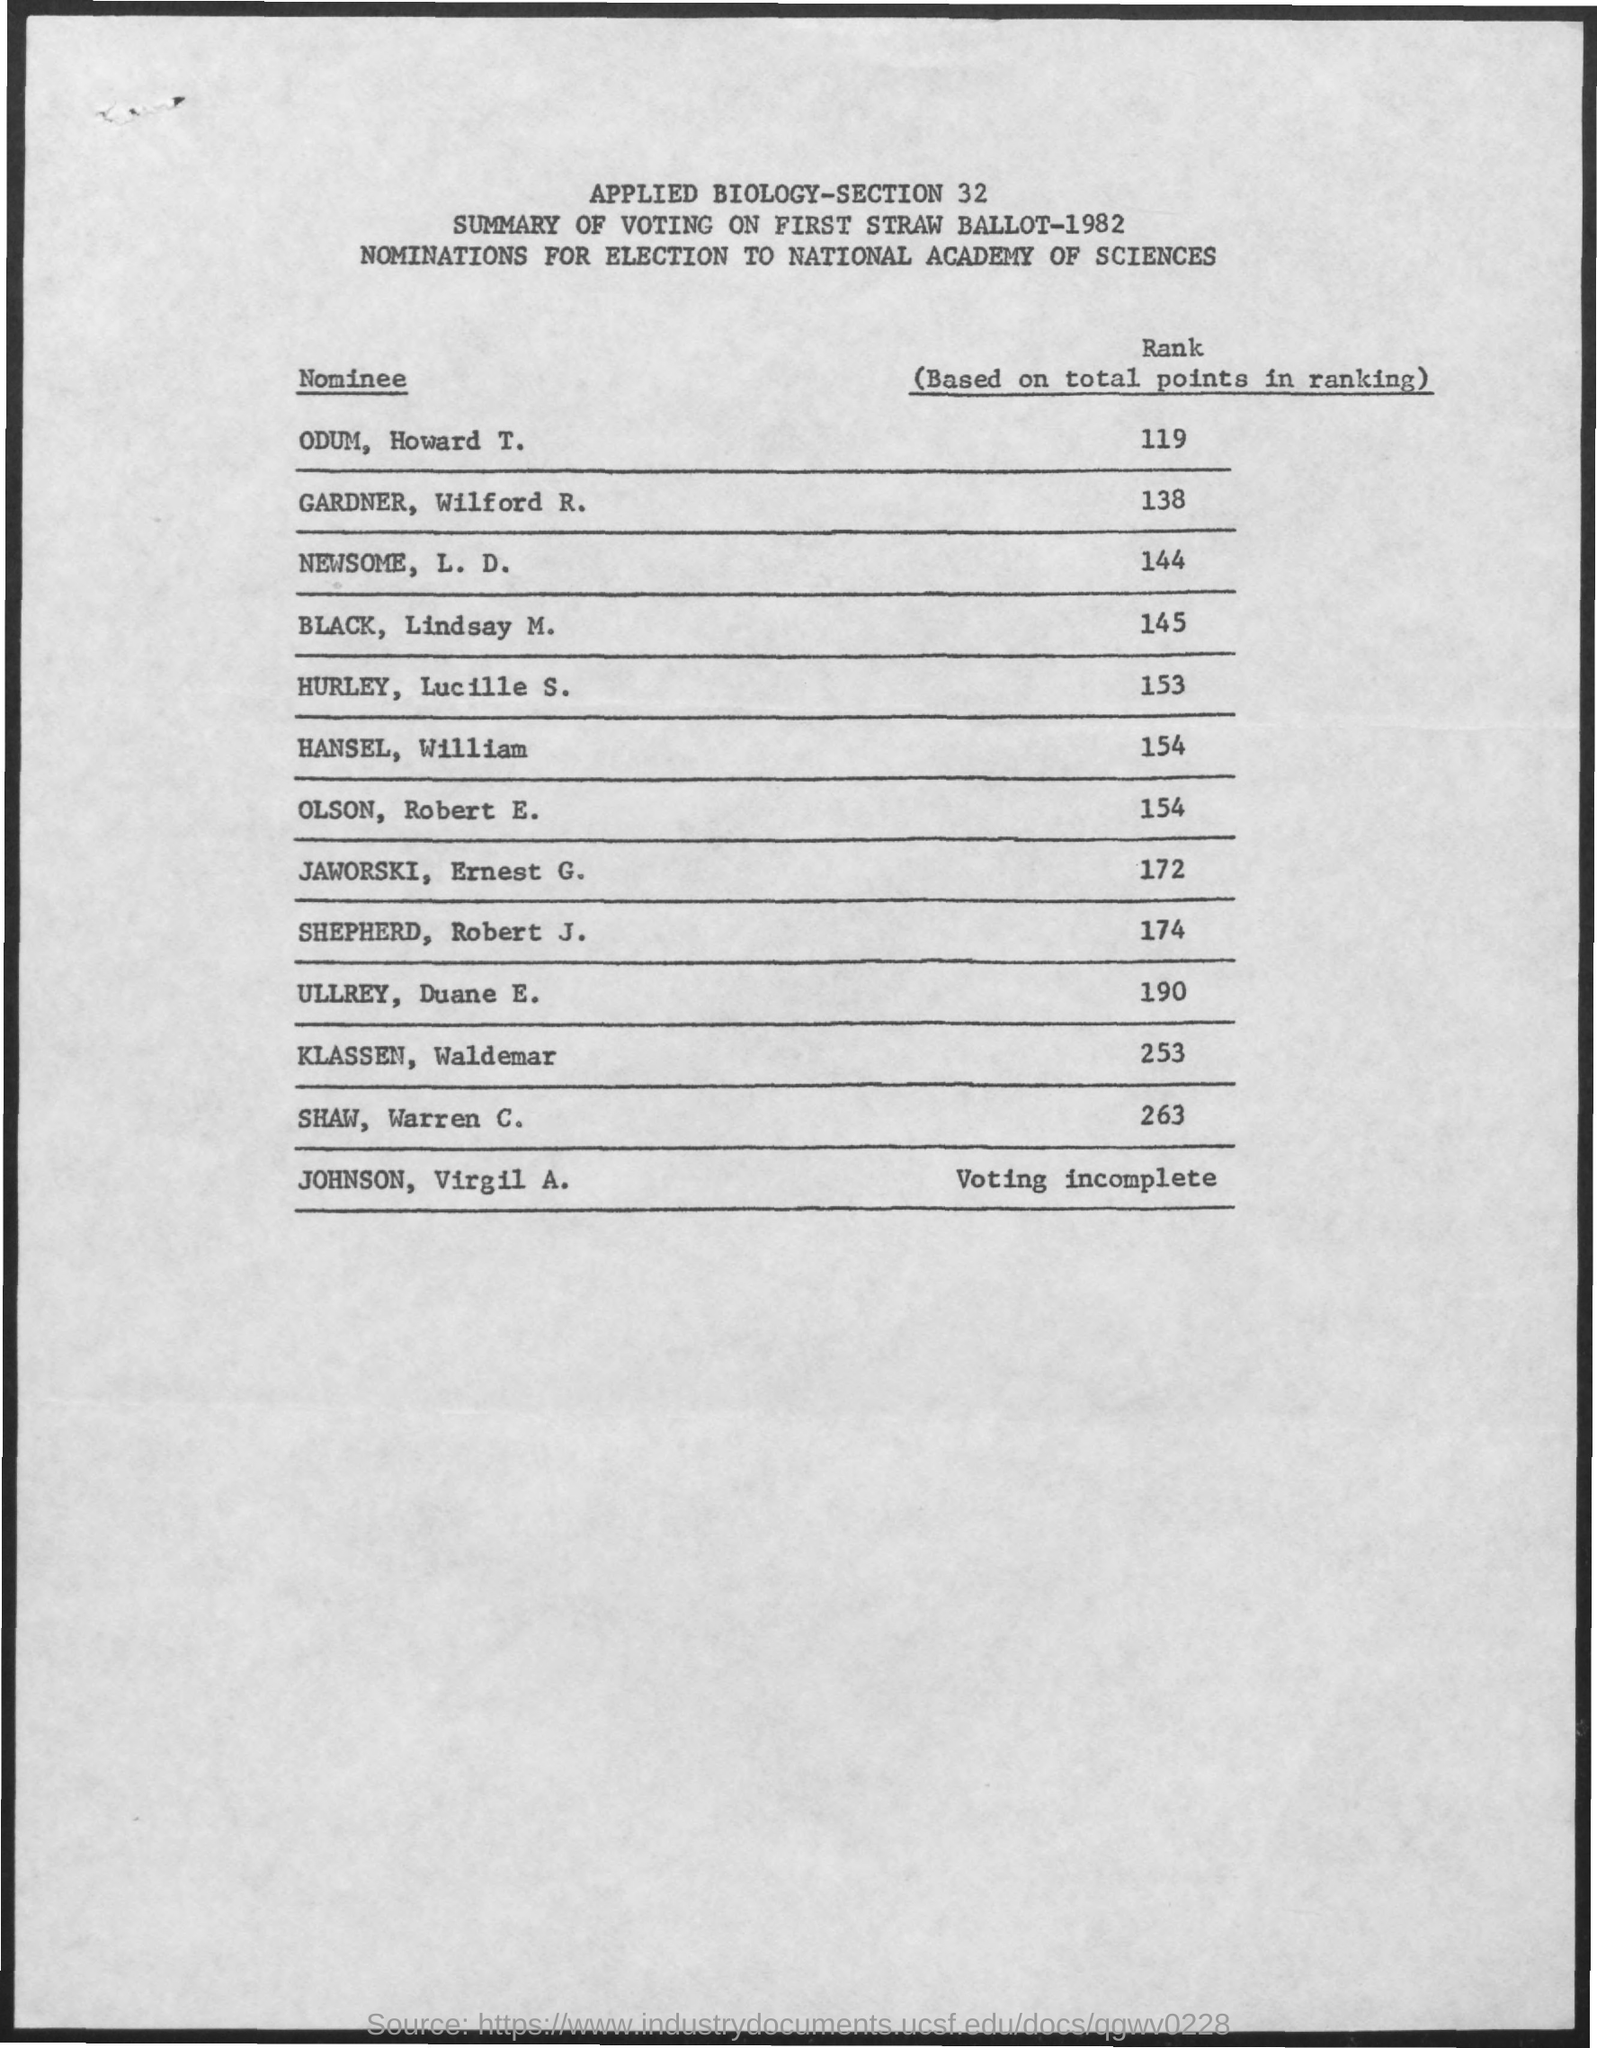Give some essential details in this illustration. The voting of JOHNSON, Virgil A., was incomplete. The nomination for the election to the National Academy of Sciences is currently in progress. Robert J. Shepherd scored 174 points. On the 18th of January, during the 1939 National Basketball League game between the Sheboygan Red Sky and the Milwaukee Hawks, Gardner, Wilford R., scored a monumental 138 points, breaking the previous record of 127 points set by Odessa Allen in 1936. Ullrey, Duane E., scored 190 points. 